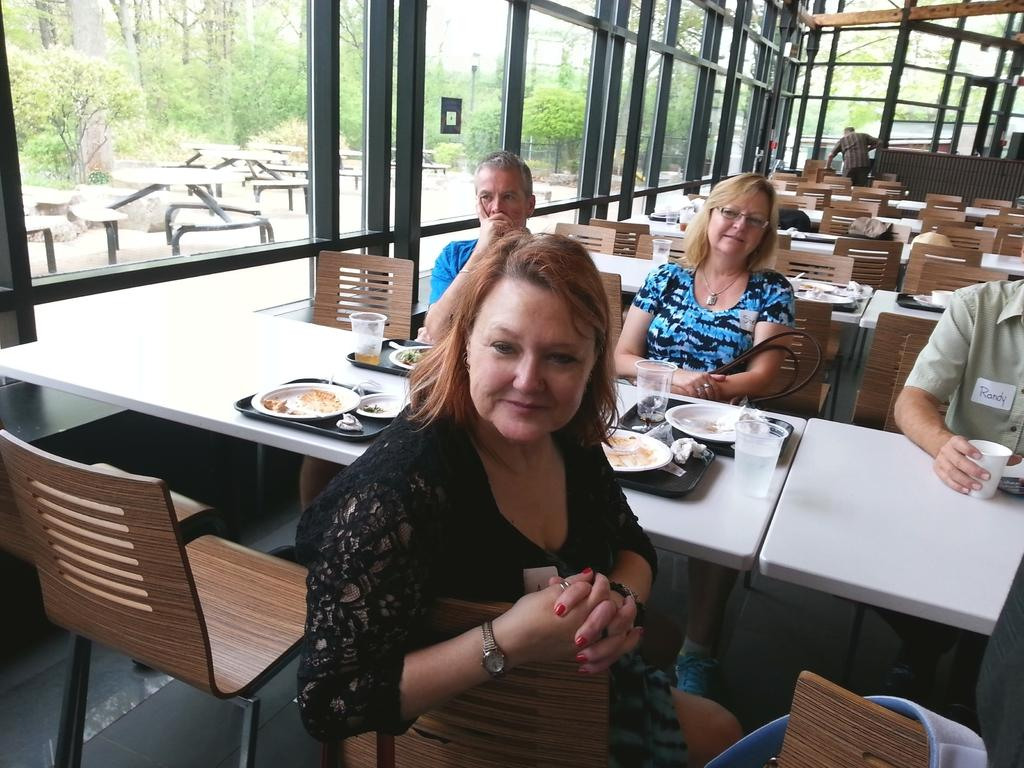How many people are in the image? There is a group of people in the image. What are the people doing in the image? The people are sitting in chairs. Where are the chairs located in relation to the table? The chairs are near a table. What can be seen in the background of the image? There is a table, a tree, the sky, and a pole in the background of the image. What type of guitar is being played by the people in the image? There is no guitar present in the image; the people are sitting in chairs near a table. 